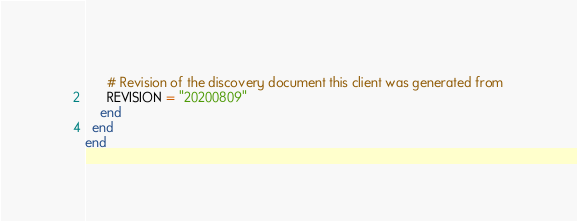<code> <loc_0><loc_0><loc_500><loc_500><_Ruby_>
      # Revision of the discovery document this client was generated from
      REVISION = "20200809"
    end
  end
end
</code> 